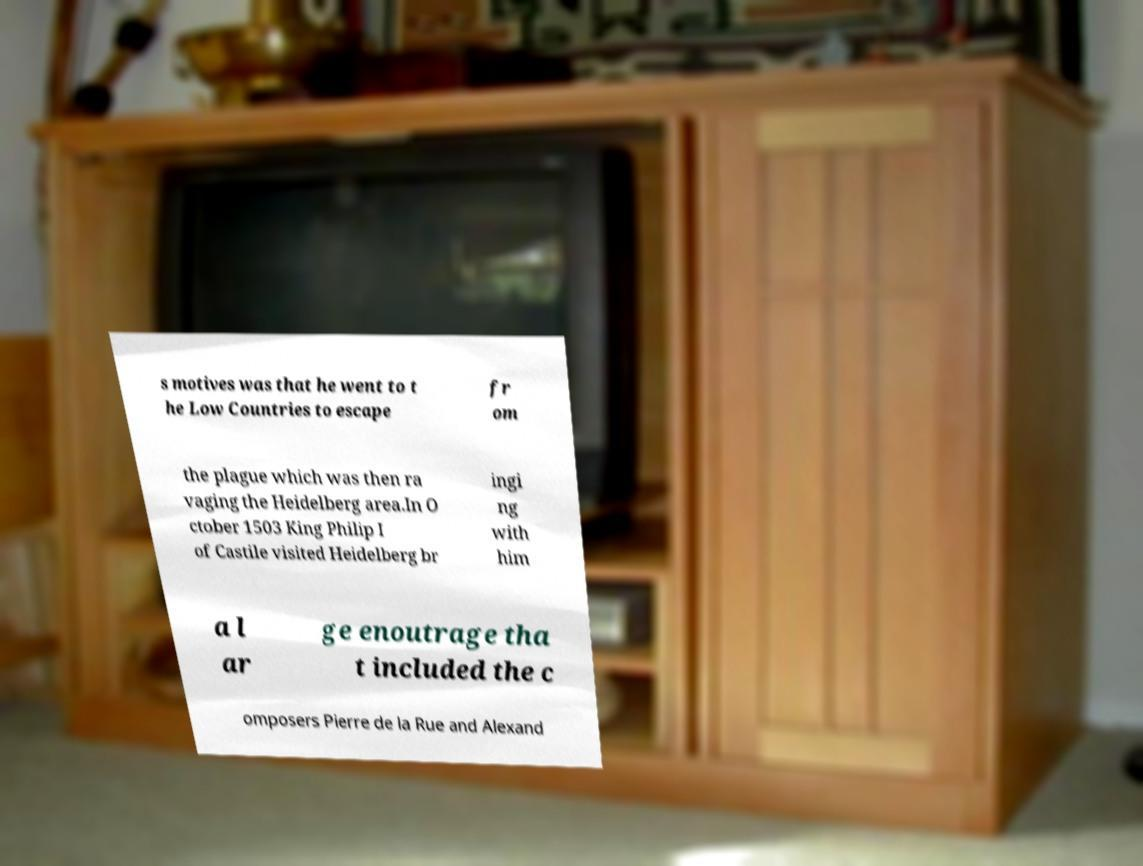I need the written content from this picture converted into text. Can you do that? s motives was that he went to t he Low Countries to escape fr om the plague which was then ra vaging the Heidelberg area.In O ctober 1503 King Philip I of Castile visited Heidelberg br ingi ng with him a l ar ge enoutrage tha t included the c omposers Pierre de la Rue and Alexand 